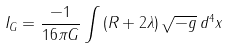<formula> <loc_0><loc_0><loc_500><loc_500>I _ { G } = \frac { - 1 } { 1 6 \pi G } \int \, ( R + 2 \lambda ) \, \sqrt { - g } \, d ^ { 4 } x</formula> 